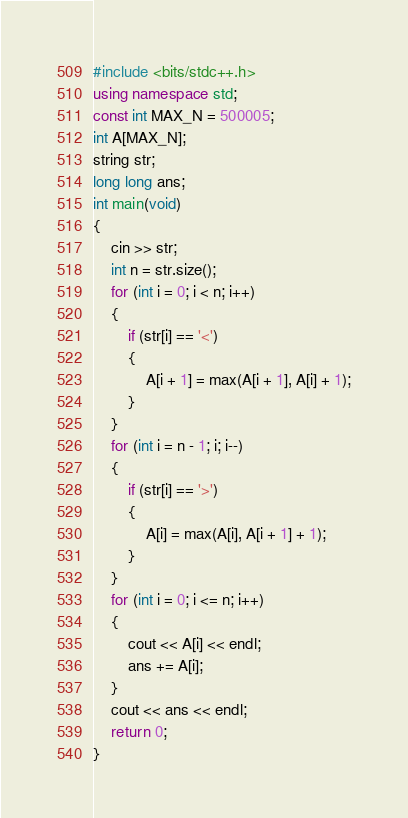<code> <loc_0><loc_0><loc_500><loc_500><_C++_>#include <bits/stdc++.h>
using namespace std;
const int MAX_N = 500005;
int A[MAX_N];
string str;
long long ans;
int main(void)
{
	cin >> str;
	int n = str.size();
	for (int i = 0; i < n; i++)
	{
		if (str[i] == '<')
		{
			A[i + 1] = max(A[i + 1], A[i] + 1);
		}
	}
	for (int i = n - 1; i; i--)
	{
		if (str[i] == '>')
		{
			A[i] = max(A[i], A[i + 1] + 1);
		}
	}
	for (int i = 0; i <= n; i++)
	{
		cout << A[i] << endl;
		ans += A[i];
	}
	cout << ans << endl;
	return 0;
}
</code> 